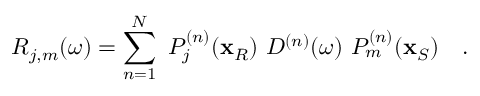<formula> <loc_0><loc_0><loc_500><loc_500>R _ { j , m } ( \omega ) = \sum _ { n = 1 } ^ { N } \, P _ { j } ^ { ( n ) } ( x _ { R } ) \, D ^ { ( n ) } ( \omega ) \, P _ { m } ^ { ( n ) } ( x _ { S } ) \quad .</formula> 